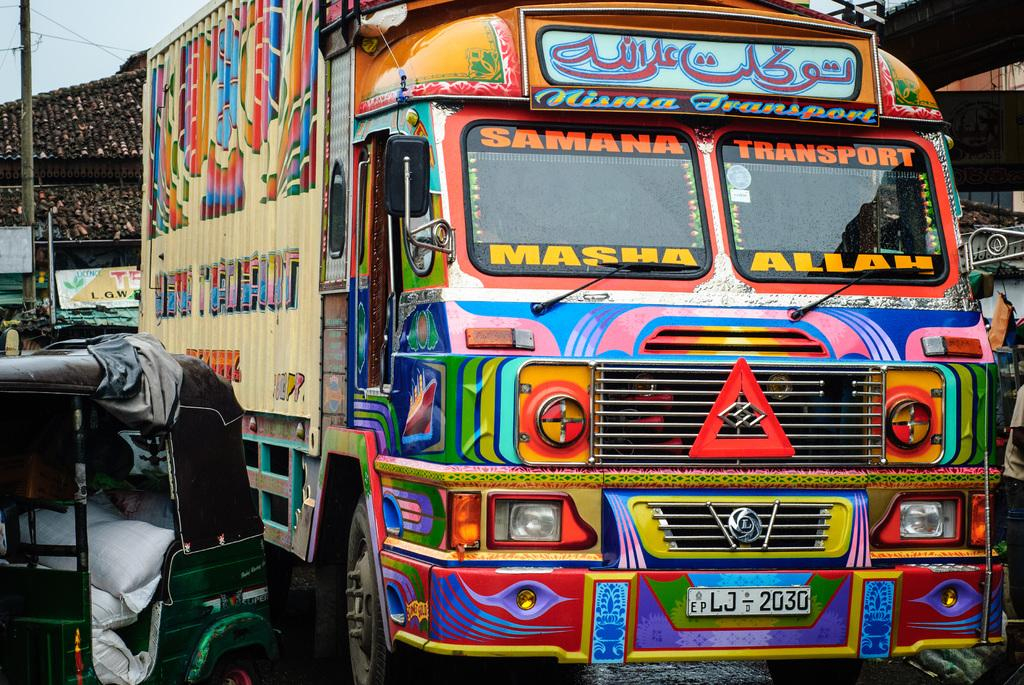What types of transportation are present in the image? There are vehicles in the image. What can be seen in the background of the image? There are boards, a pole, a roof, and the sky visible in the background of the image. How many boats are visible in the image? There are no boats present in the image. What is the ear used for in the image? There is no ear present in the image. 